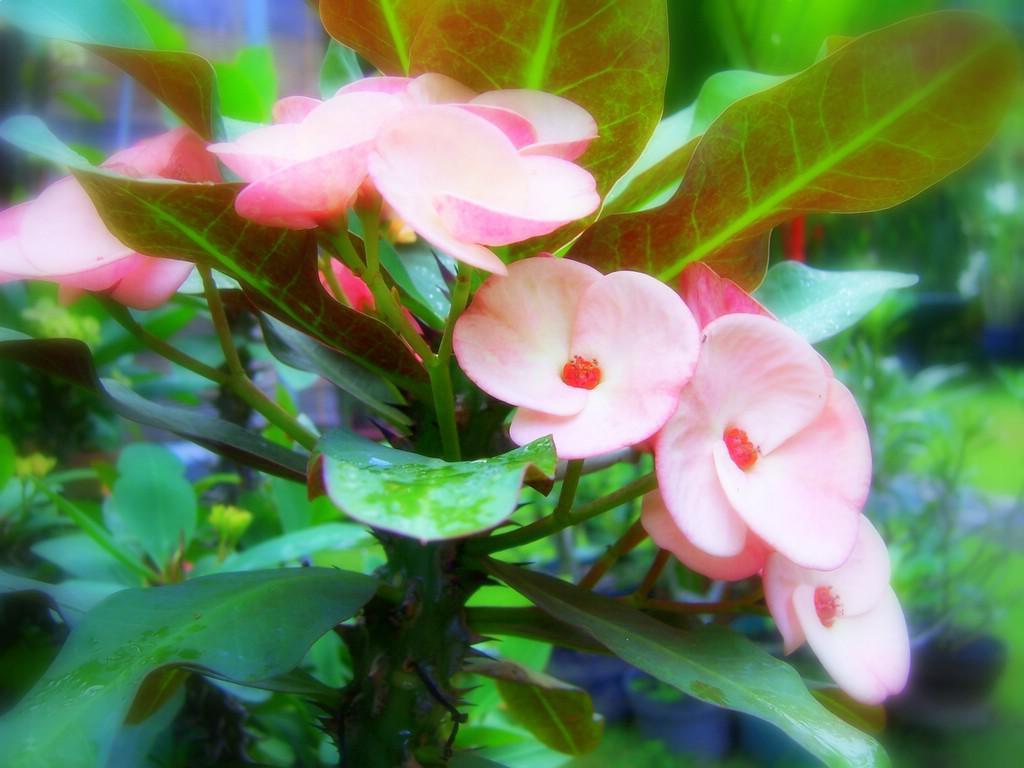How would you summarize this image in a sentence or two? In this image in the foreground there are some plants, and in the background also there are some plants. 